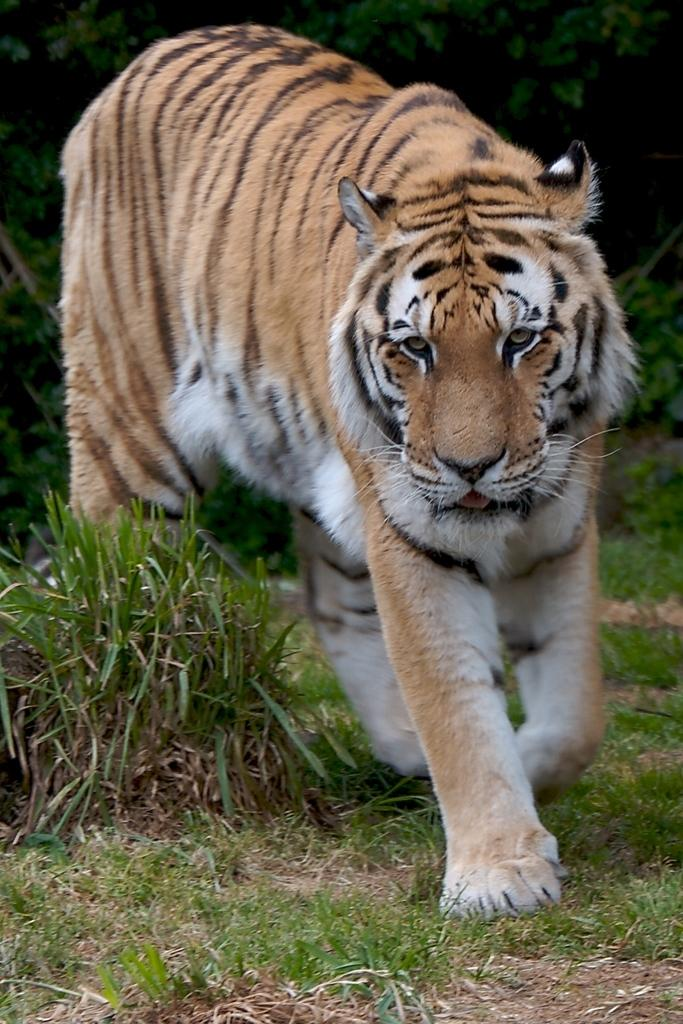What animal is in the image? There is a tiger in the image. Where is the tiger located? The tiger is on the ground. What can be seen in the background of the image? There are trees in the background of the image. What type of skirt is the governor wearing in the image? There is no governor or skirt present in the image; it features a tiger on the ground with trees in the background. 